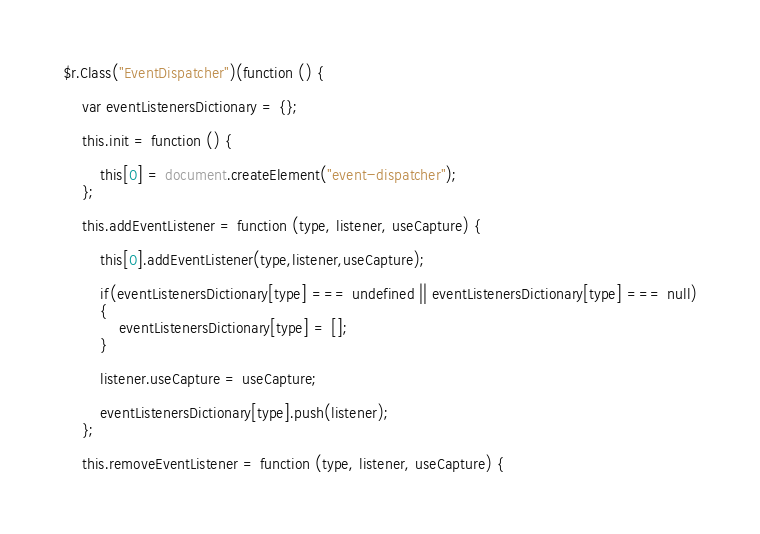<code> <loc_0><loc_0><loc_500><loc_500><_JavaScript_>$r.Class("EventDispatcher")(function () {

    var eventListenersDictionary = {};

    this.init = function () {

        this[0] = document.createElement("event-dispatcher");
    };

    this.addEventListener = function (type, listener, useCapture) {

        this[0].addEventListener(type,listener,useCapture);

        if(eventListenersDictionary[type] === undefined || eventListenersDictionary[type] === null)
        {
            eventListenersDictionary[type] = [];
        }

        listener.useCapture = useCapture;

        eventListenersDictionary[type].push(listener);
    };

    this.removeEventListener = function (type, listener, useCapture) {</code> 